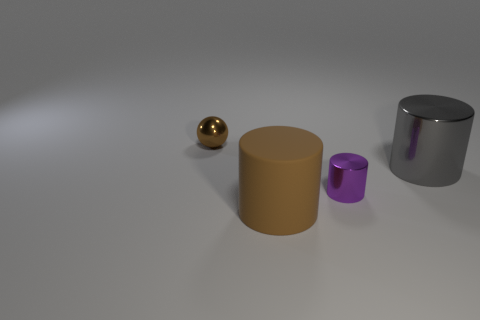Add 2 large red cubes. How many objects exist? 6 Subtract all cylinders. How many objects are left? 1 Add 2 large gray metallic objects. How many large gray metallic objects are left? 3 Add 1 balls. How many balls exist? 2 Subtract 0 gray balls. How many objects are left? 4 Subtract all tiny brown metal balls. Subtract all small things. How many objects are left? 1 